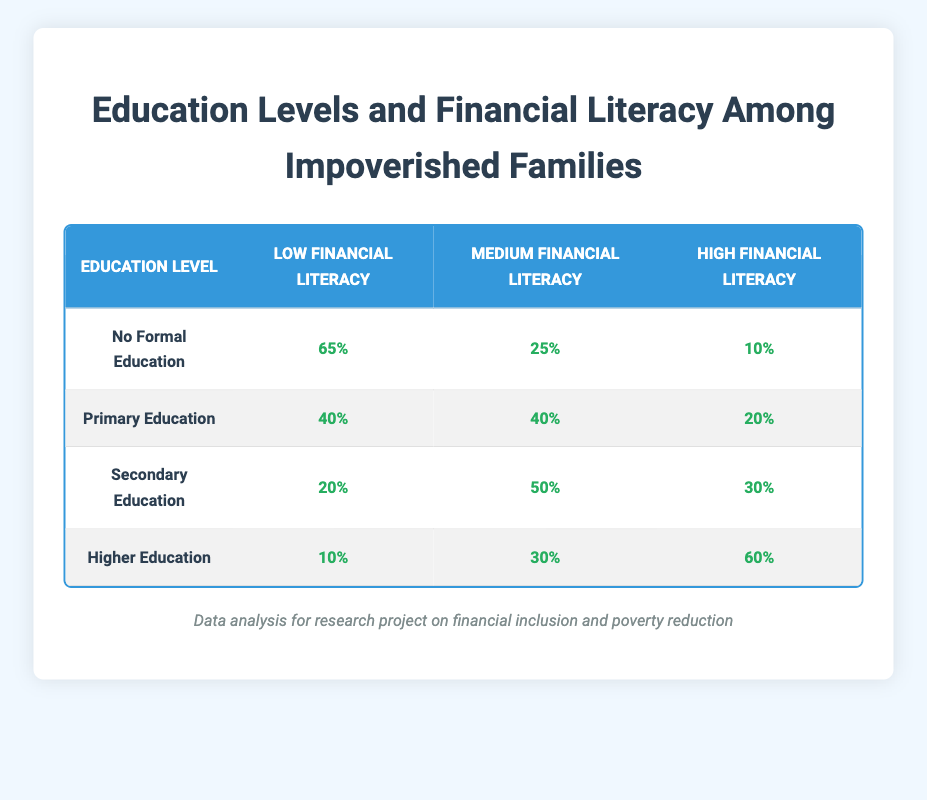What percentage of individuals with no formal education have low financial literacy? According to the table, the percentage of individuals with no formal education that have low financial literacy is explicitly listed. It is stated as 65%.
Answer: 65% What is the financial literacy percentage of those with higher education? The table provides the financial literacy percentages for each level of education. For higher education, the percentages are 10% low, 30% medium, and 60% high.
Answer: 10% low, 30% medium, 60% high How many individuals educated at the secondary level have medium financial literacy? Looking at the table, the second column for secondary education shows that 50% have medium financial literacy, indicating that this is a specific and straightforward retrieval of data.
Answer: 50% Is it true that more than half of the individuals with primary education have low financial literacy? The table shows that 40% of individuals with primary education have low financial literacy. Since 40% is less than 50%, the statement is false.
Answer: No What is the difference in percentage between low financial literacy among those with no formal education and those with secondary education? From the table, we see that the percentage for low financial literacy for no formal education is 65% and for secondary education is 20%. The difference is calculated as 65% - 20% = 45%. Therefore, the difference in low financial literacy percentage between these two education levels is 45%.
Answer: 45% What percentage of individuals with higher education have a high level of financial literacy? The table indicates that 60% of those who attained higher education have a high level of financial literacy, providing a straightforward retrieval of data from the table.
Answer: 60% What is the average percentage of low financial literacy across all education levels? The percentages for low financial literacy across the education levels are 65%, 40%, 20%, and 10%. To find the average, we add these percentages: 65 + 40 + 20 + 10 = 135. There are 4 education levels, so the average is 135/4 = 33.75%.
Answer: 33.75% Is it accurate that individuals with secondary education have equal or less financial literacy than those with primary education? Reviewing the table, secondary education has 20% low, 50% medium, and 30% high, while primary education has 40% low, 40% medium, and 20% high. Hence, secondary education individuals do have equal or less low financial literacy than primary education individuals, making the statement true.
Answer: Yes What percentage of individuals with primary education have high financial literacy compared to those with higher education? For primary education, 20% have high financial literacy, while for higher education, 60% have high financial literacy. The difference is calculated as 60% - 20% = 40%, and thus, the percentage of high financial literacy is higher for higher education by 40%.
Answer: Higher by 40% 